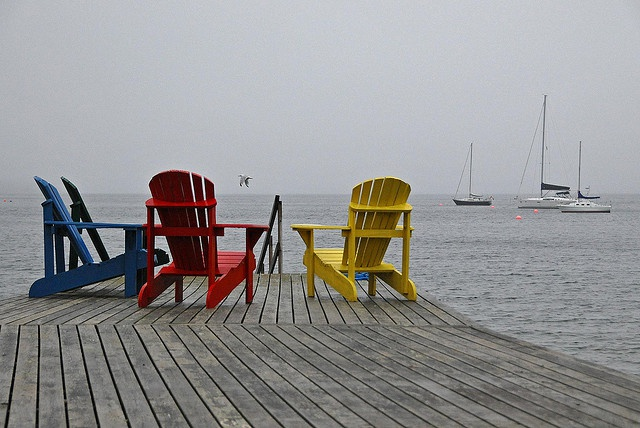Describe the objects in this image and their specific colors. I can see chair in darkgray, black, maroon, and brown tones, chair in darkgray, olive, and maroon tones, chair in darkgray, black, navy, and blue tones, boat in darkgray, lightgray, and gray tones, and boat in darkgray, gray, and black tones in this image. 